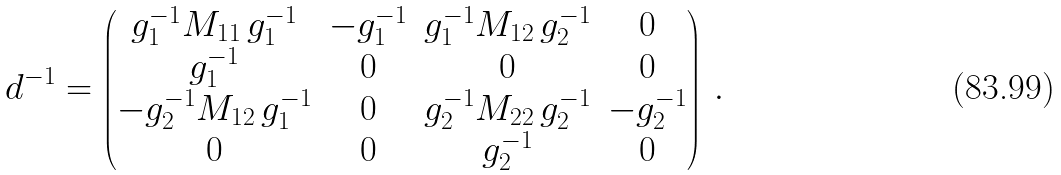Convert formula to latex. <formula><loc_0><loc_0><loc_500><loc_500>d ^ { - 1 } = \begin{pmatrix} g _ { 1 } ^ { - 1 } M _ { 1 1 } \, g _ { 1 } ^ { - 1 } & - g _ { 1 } ^ { - 1 } & g _ { 1 } ^ { - 1 } M _ { 1 2 } \, g _ { 2 } ^ { - 1 } & 0 \\ g _ { 1 } ^ { - 1 } & 0 & 0 & 0 \\ - g _ { 2 } ^ { - 1 } M _ { 1 2 } \, g _ { 1 } ^ { - 1 } & 0 & g _ { 2 } ^ { - 1 } M _ { 2 2 } \, g _ { 2 } ^ { - 1 } & - g _ { 2 } ^ { - 1 } \\ 0 & 0 & g _ { 2 } ^ { - 1 } & 0 \end{pmatrix} \, .</formula> 